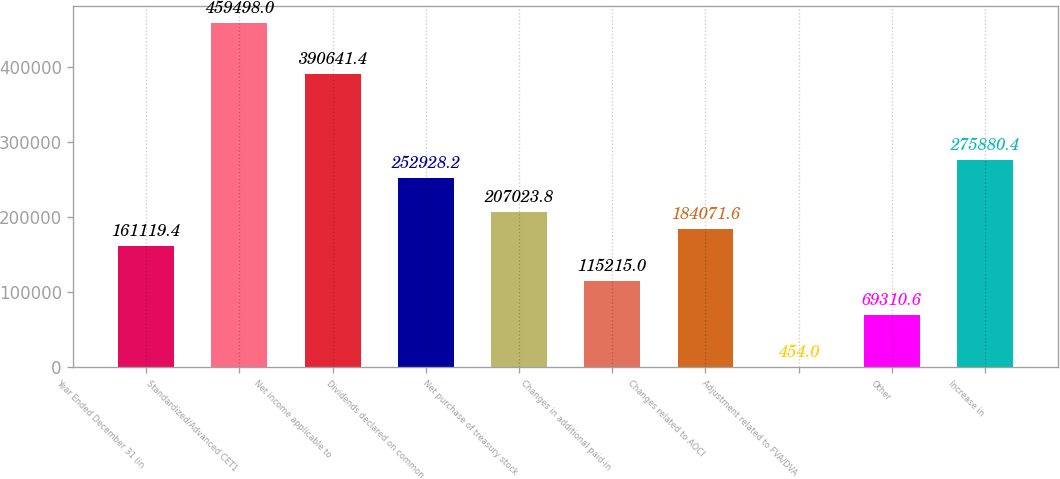<chart> <loc_0><loc_0><loc_500><loc_500><bar_chart><fcel>Year Ended December 31 (in<fcel>Standardized/Advanced CET1<fcel>Net income applicable to<fcel>Dividends declared on common<fcel>Net purchase of treasury stock<fcel>Changes in additional paid-in<fcel>Changes related to AOCI<fcel>Adjustment related to FVA/DVA<fcel>Other<fcel>Increase in<nl><fcel>161119<fcel>459498<fcel>390641<fcel>252928<fcel>207024<fcel>115215<fcel>184072<fcel>454<fcel>69310.6<fcel>275880<nl></chart> 